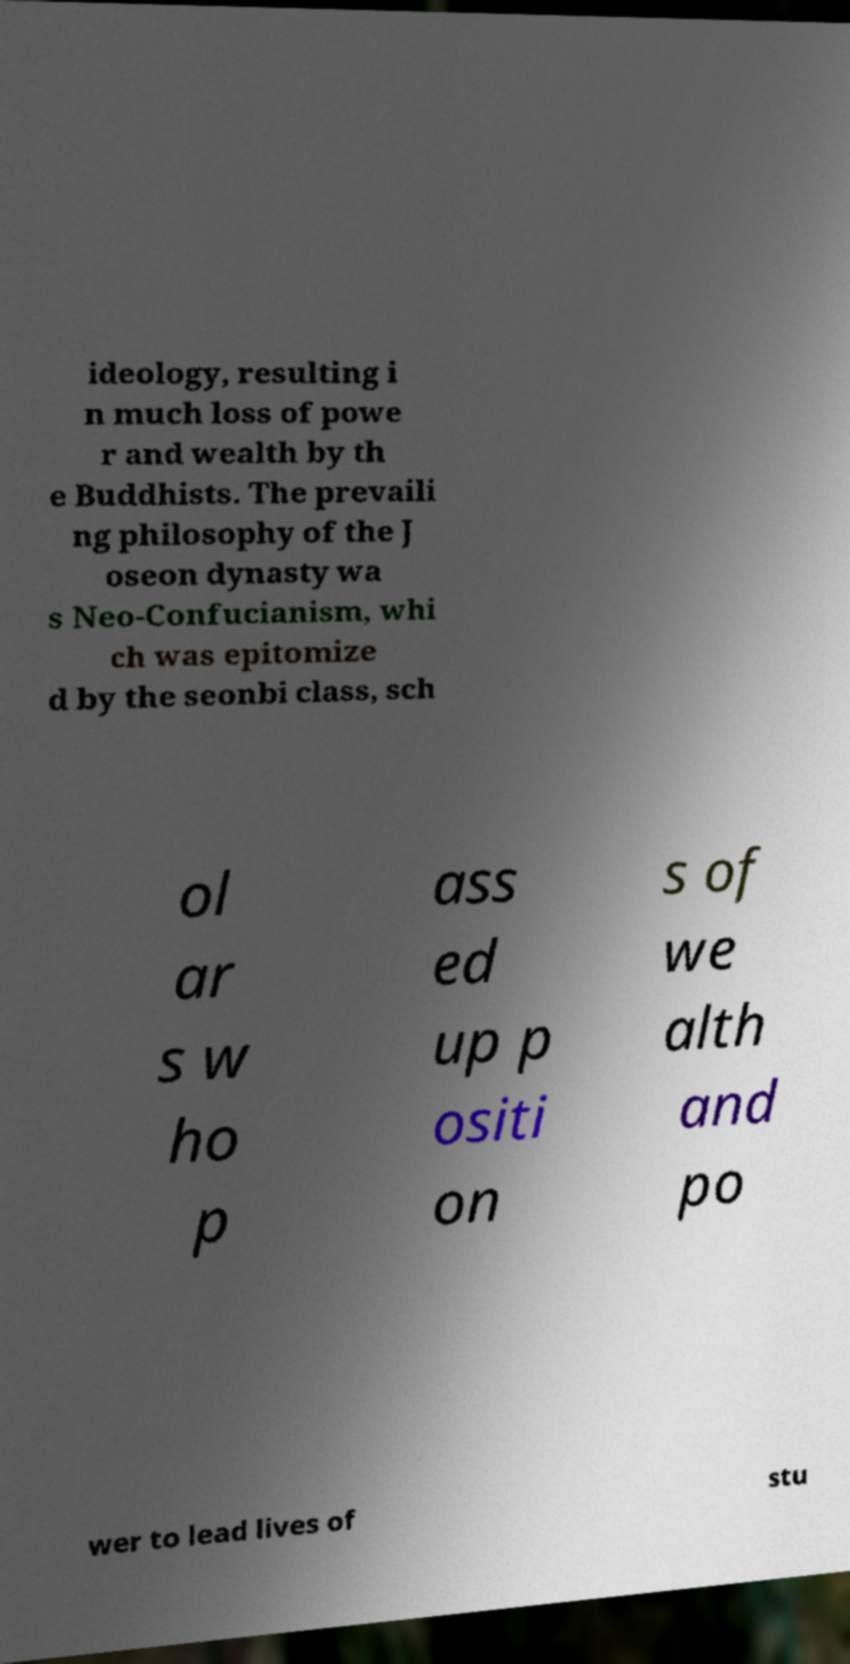Can you read and provide the text displayed in the image?This photo seems to have some interesting text. Can you extract and type it out for me? ideology, resulting i n much loss of powe r and wealth by th e Buddhists. The prevaili ng philosophy of the J oseon dynasty wa s Neo-Confucianism, whi ch was epitomize d by the seonbi class, sch ol ar s w ho p ass ed up p ositi on s of we alth and po wer to lead lives of stu 